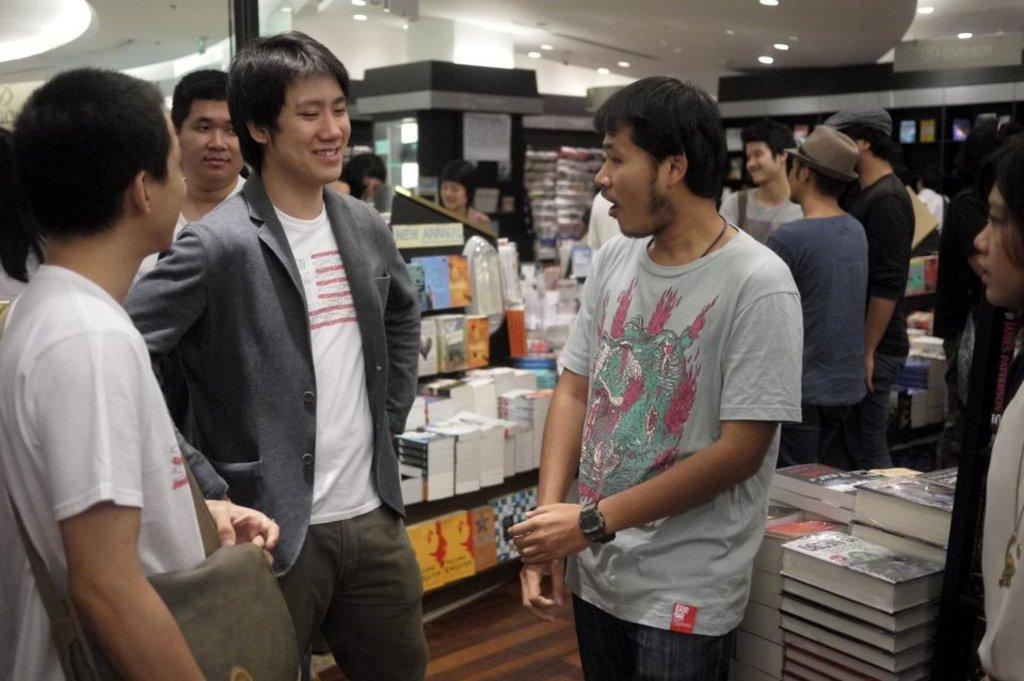Describe this image in one or two sentences. It looks like a book store many people were standing in between the the books and in the front two people were discussing with each other, there are white color lights to the ceiling. 